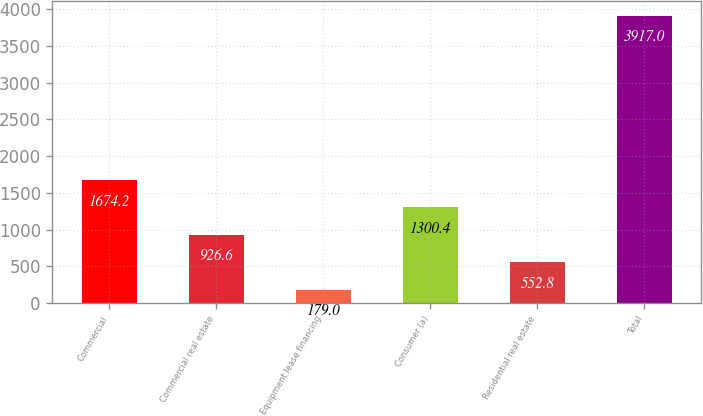Convert chart to OTSL. <chart><loc_0><loc_0><loc_500><loc_500><bar_chart><fcel>Commercial<fcel>Commercial real estate<fcel>Equipment lease financing<fcel>Consumer (a)<fcel>Residential real estate<fcel>Total<nl><fcel>1674.2<fcel>926.6<fcel>179<fcel>1300.4<fcel>552.8<fcel>3917<nl></chart> 